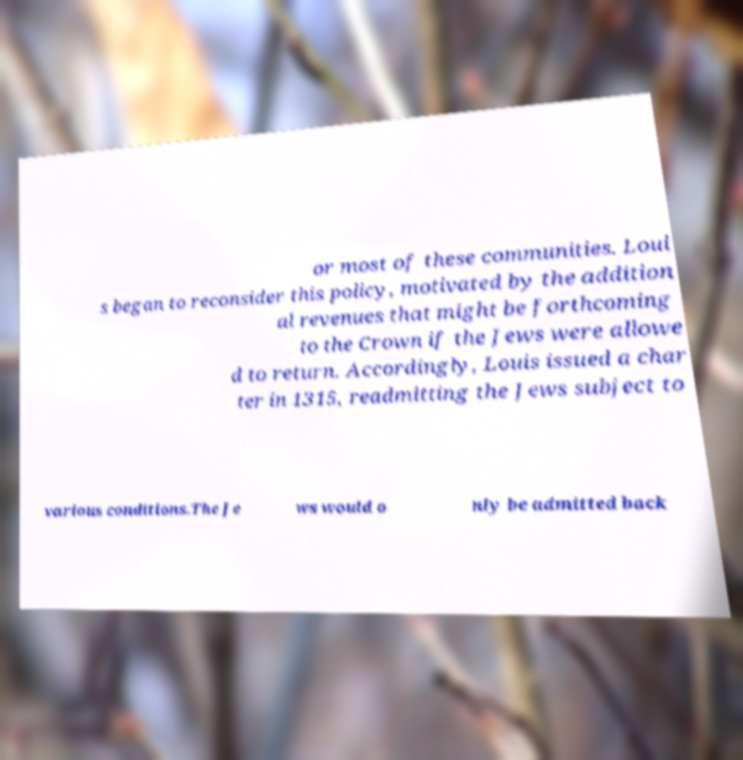What messages or text are displayed in this image? I need them in a readable, typed format. or most of these communities. Loui s began to reconsider this policy, motivated by the addition al revenues that might be forthcoming to the Crown if the Jews were allowe d to return. Accordingly, Louis issued a char ter in 1315, readmitting the Jews subject to various conditions.The Je ws would o nly be admitted back 